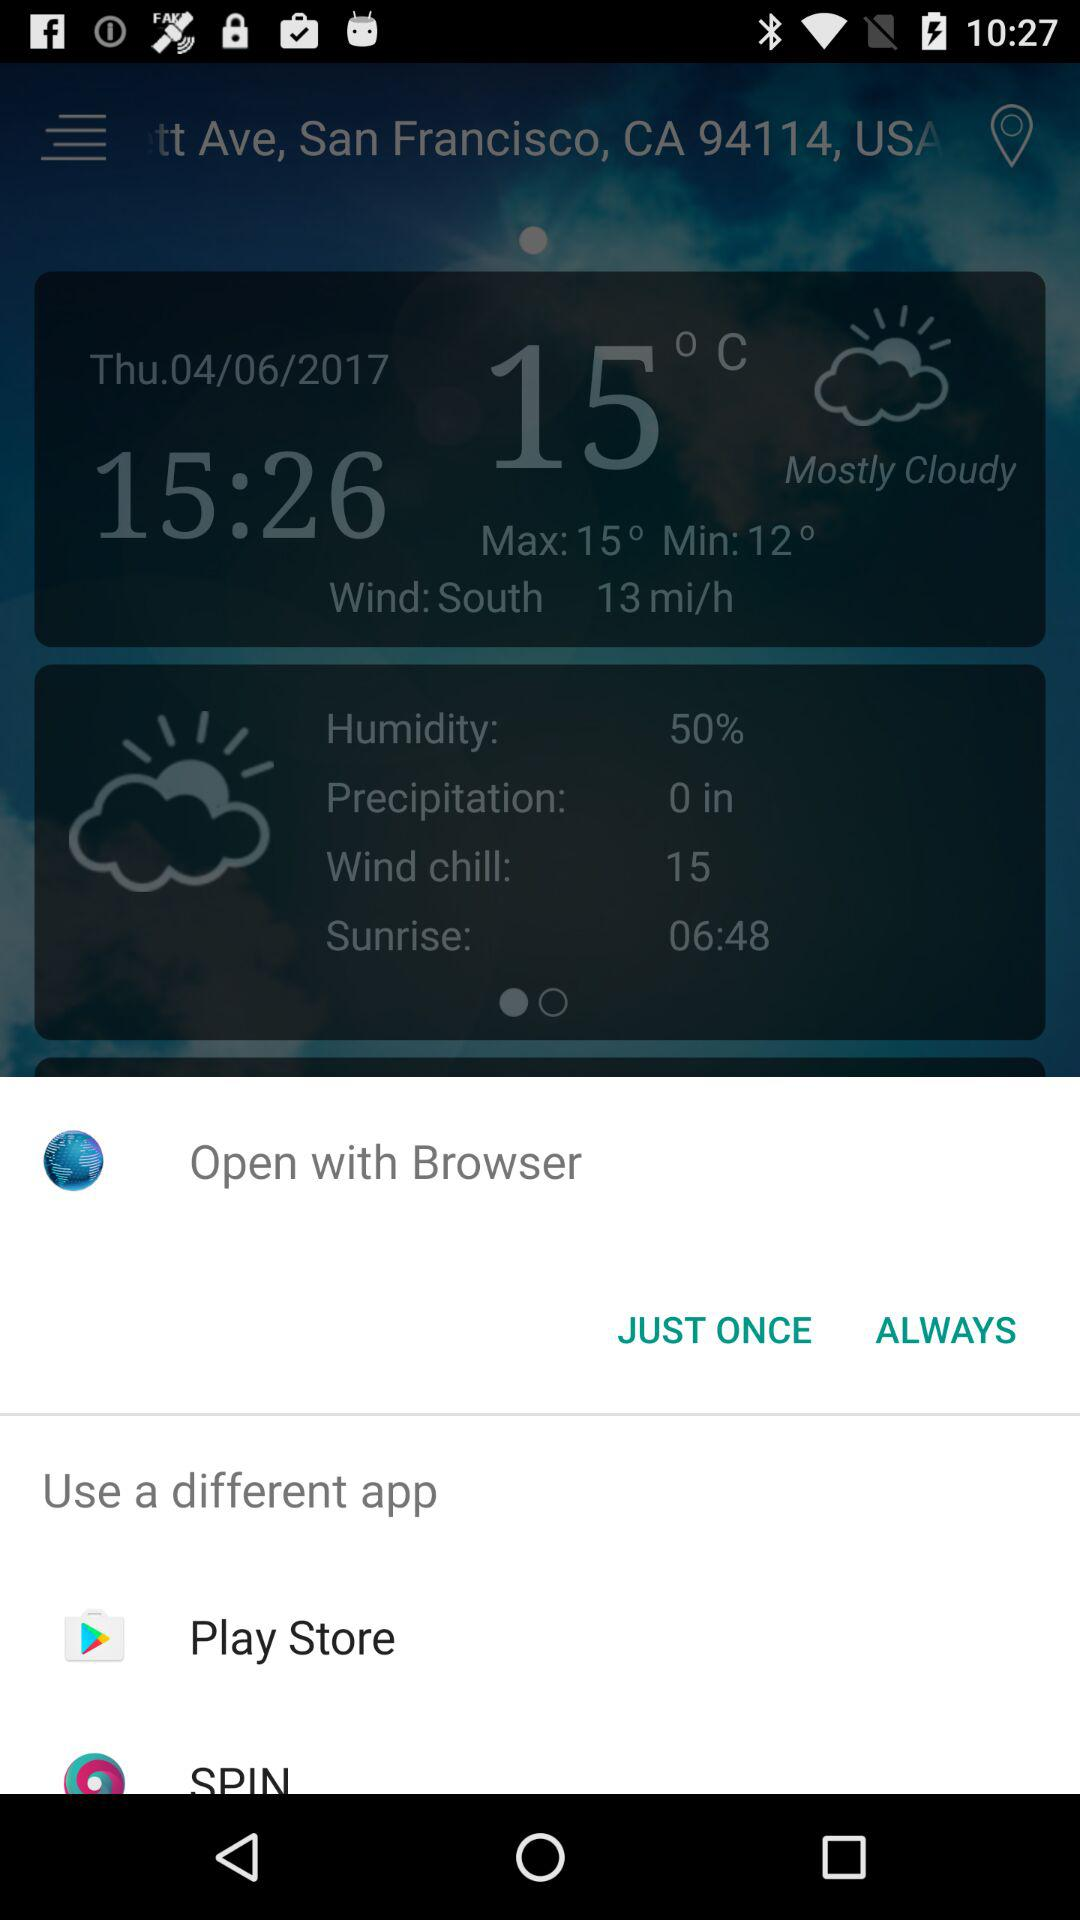What is the mentioned date? The mentioned date is Thursday, April 6, 2017. 